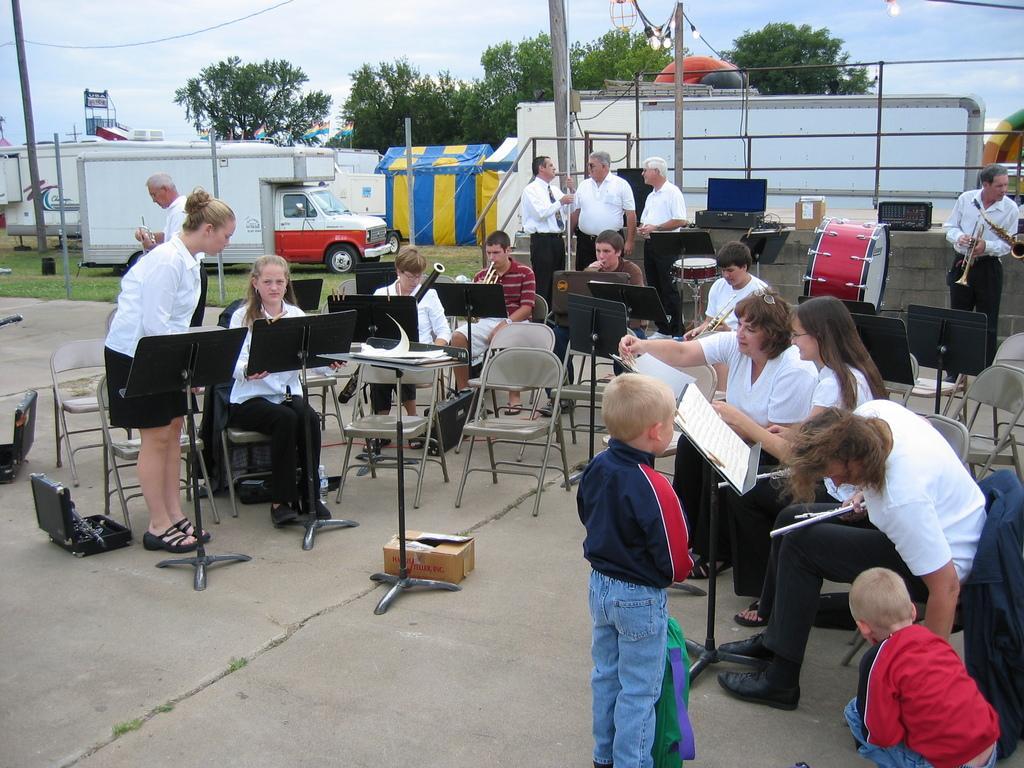Can you describe this image briefly? In this image we can see chairs, stands, persons, books, musical instruments, van, tents, trees, sky and clouds. 